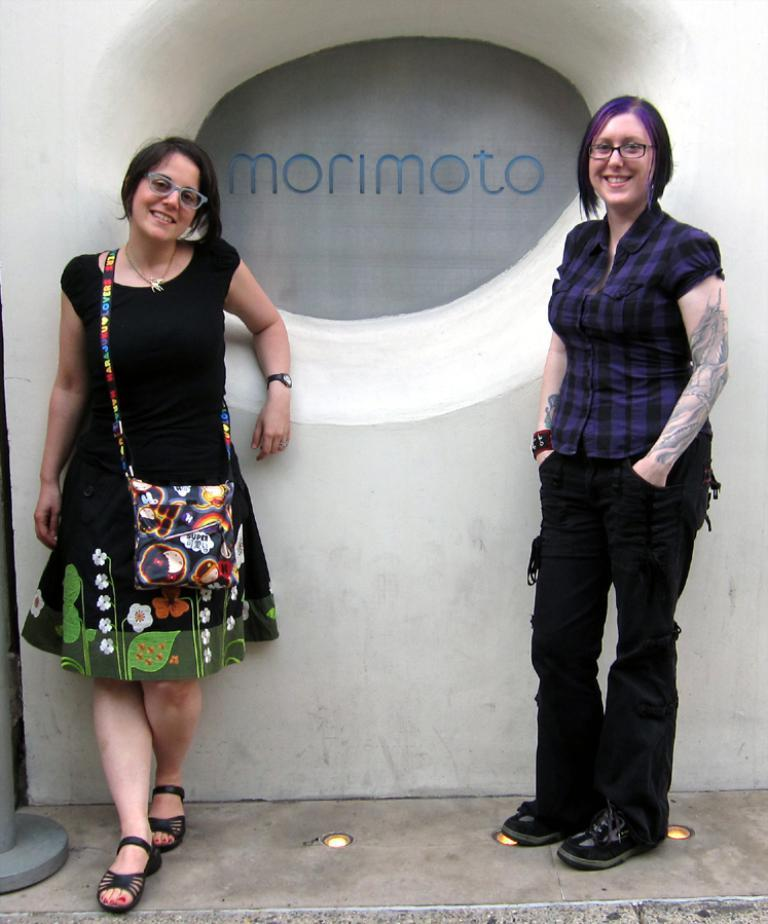How many people are in the image? There are two ladies in the image. What are the ladies wearing? One lady is wearing a blue and black shirt with black pants, and the other lady is wearing a black gown. What are the ladies doing in the image? Both ladies are standing. What type of stamp can be seen on the ladies' clothing in the image? There is no stamp visible on the ladies' clothing in the image. Is there a bathtub present in the image? There is no bathtub or any indication of a bathing activity in the image. 